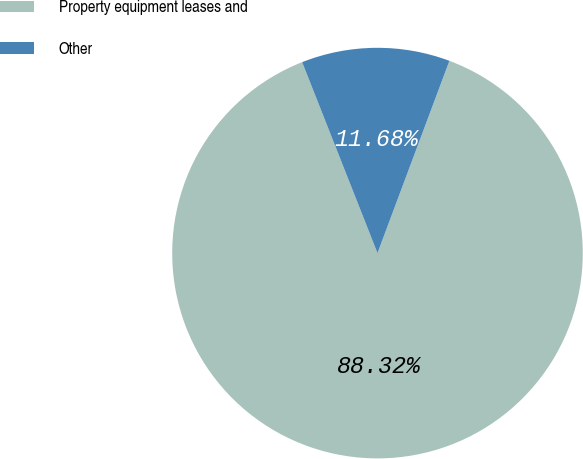<chart> <loc_0><loc_0><loc_500><loc_500><pie_chart><fcel>Property equipment leases and<fcel>Other<nl><fcel>88.32%<fcel>11.68%<nl></chart> 